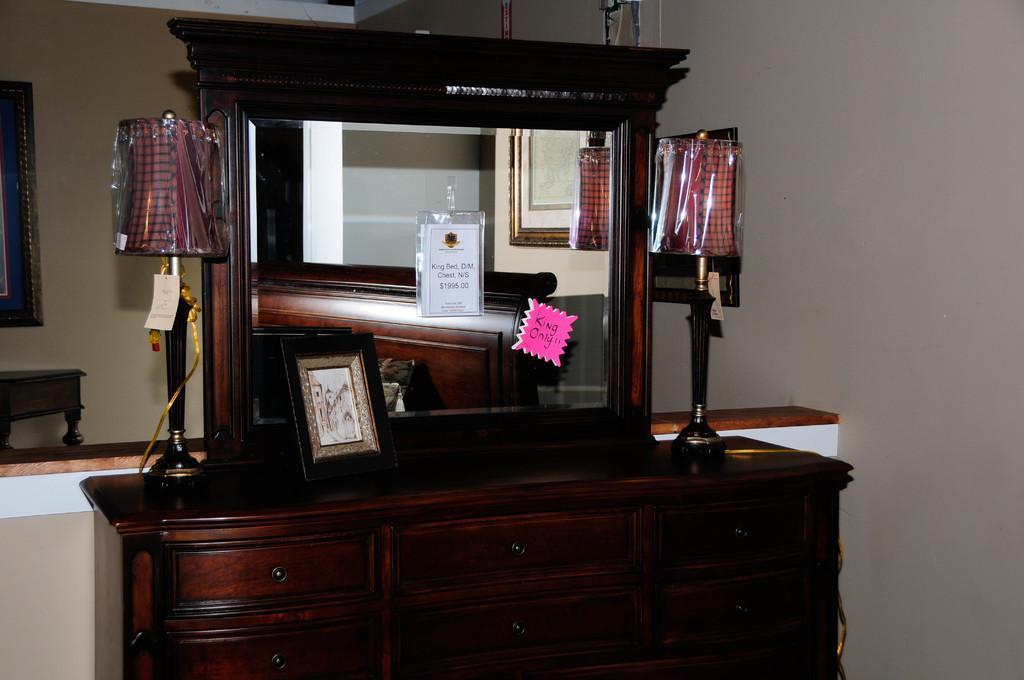Please provide a concise description of this image. In this image we can see a cupboard with a mirror. On the cupboard there is a photo frame and there are lamps. There are drawers for the cupboard. On the mirror there are two things pasted. In the back there is a wall. And we can see a photo frame on the left side. 